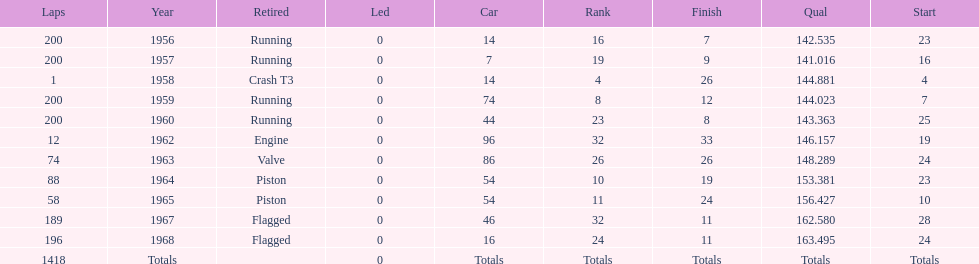What year did he have the same number car as 1964? 1965. 